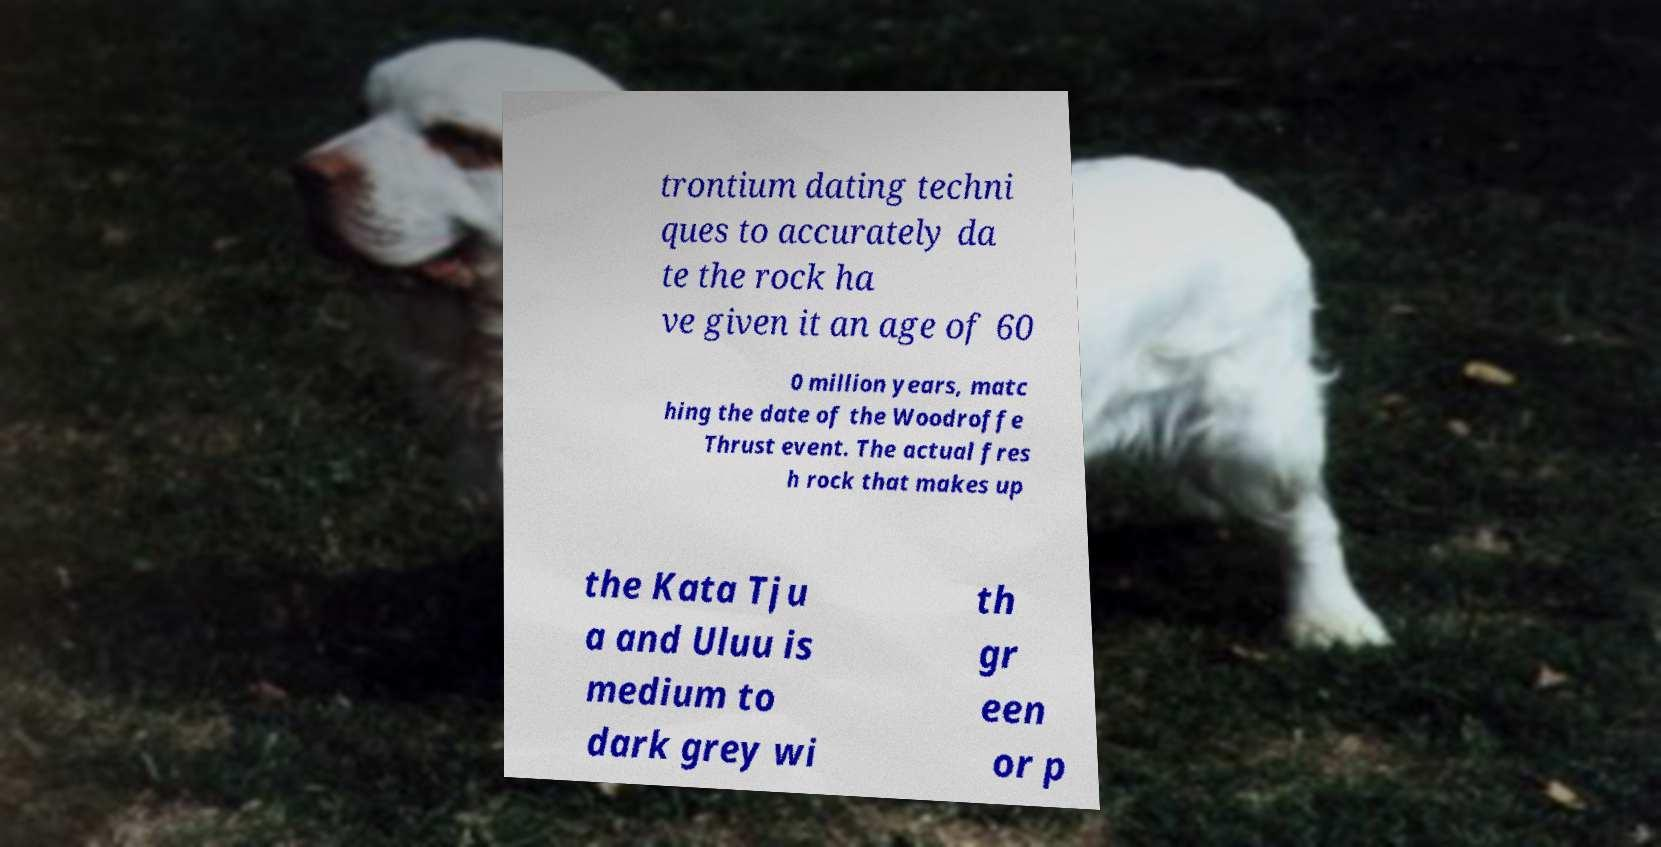Can you read and provide the text displayed in the image?This photo seems to have some interesting text. Can you extract and type it out for me? trontium dating techni ques to accurately da te the rock ha ve given it an age of 60 0 million years, matc hing the date of the Woodroffe Thrust event. The actual fres h rock that makes up the Kata Tju a and Uluu is medium to dark grey wi th gr een or p 